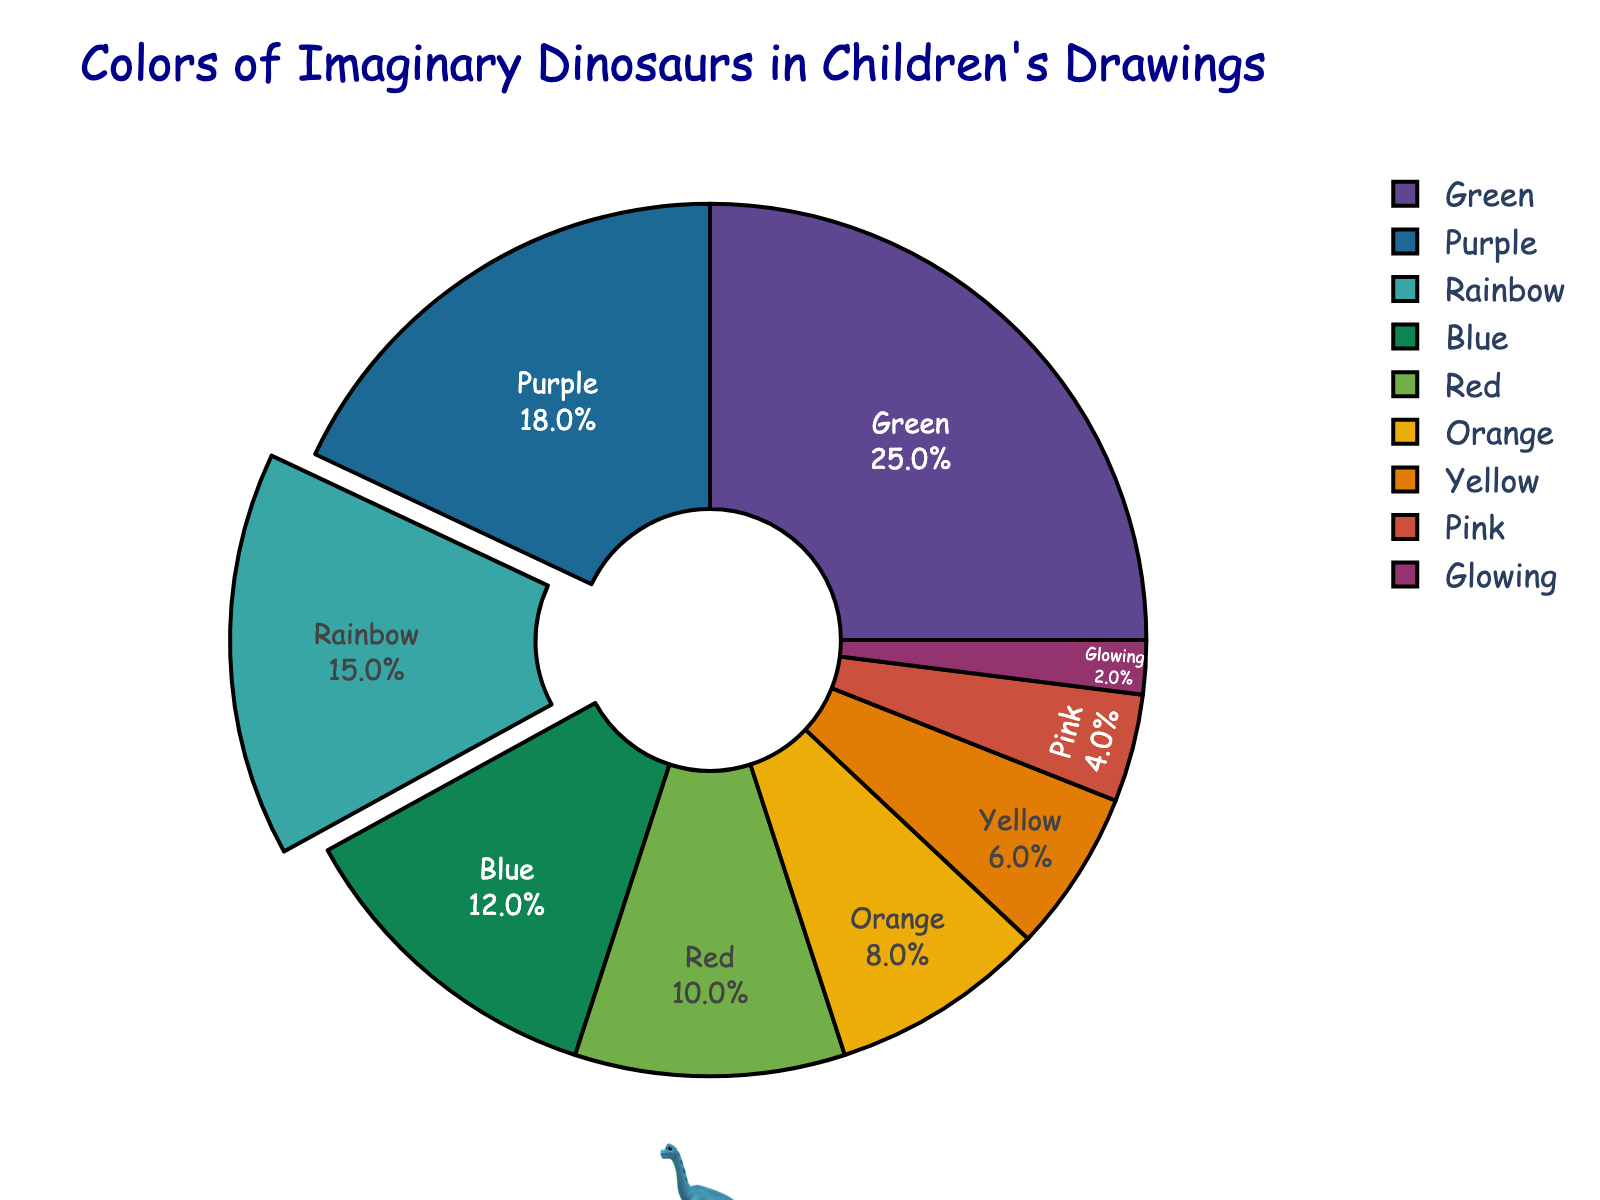What color has the highest percentage in the pie chart? Green has the highest percentage. You can see that "Green" has the largest slice of the pie chart, with a label showing 25%.
Answer: Green Which two colors together make up less than 10% of the pie chart? The slices for "Pink" and "Glowing" are the smallest. The pie chart shows "Pink" at 4% and "Glowing" at 2%. Adding these percentages, 4% + 2% = 6%, which is less than 10%.
Answer: Pink and Glowing What’s the difference in percentage between the colors Blue and Red? The percentage for Blue is 12% and for Red is 10%. So, the difference is 12% - 10% = 2%.
Answer: 2% How many colors have a percentage higher than 10%? From the pie chart, "Green" (25%), "Purple" (18%), "Rainbow" (15%), and "Blue" (12%) each have percentages higher than 10%. Counting these gives us 4 colors.
Answer: 4 Which color has exactly half the percentage of the green color? The green color has a percentage of 25%. Half of 25% is 12.5%. Since no color has exactly 12.5%, we need to check closely related values. The closest is the Blue color, but it has 12%, which is very close to half of the Green color.
Answer: Blue How much more is the combined percentage of Orange and Yellow compared to Red? Orange has 8%, and Yellow has 6%. Adding these together, 8% + 6% = 14%. Red has 10%. Therefore, 14% - 10% = 4%.
Answer: 4% Which color appears smallest in the pie chart? Looking at the slices, "Glowing" has the smallest percentage, which is indicated as 2%.
Answer: Glowing What’s the combined percentage of the top three most frequent colors? The top three colors are Green (25%), Purple (18%), and Rainbow (15%). Their combined percentage is 25% + 18% + 15% = 58%.
Answer: 58% Which visual element is used to highlight the Rainbow color in the chart? The Rainbow color slice is slightly pulled out from the pie chart to emphasize it.
Answer: Pull-out effect What percentage does the slice for Pink color cover in the pie chart? The pie chart shows that the Pink color covers 4% of the chart.
Answer: 4% 